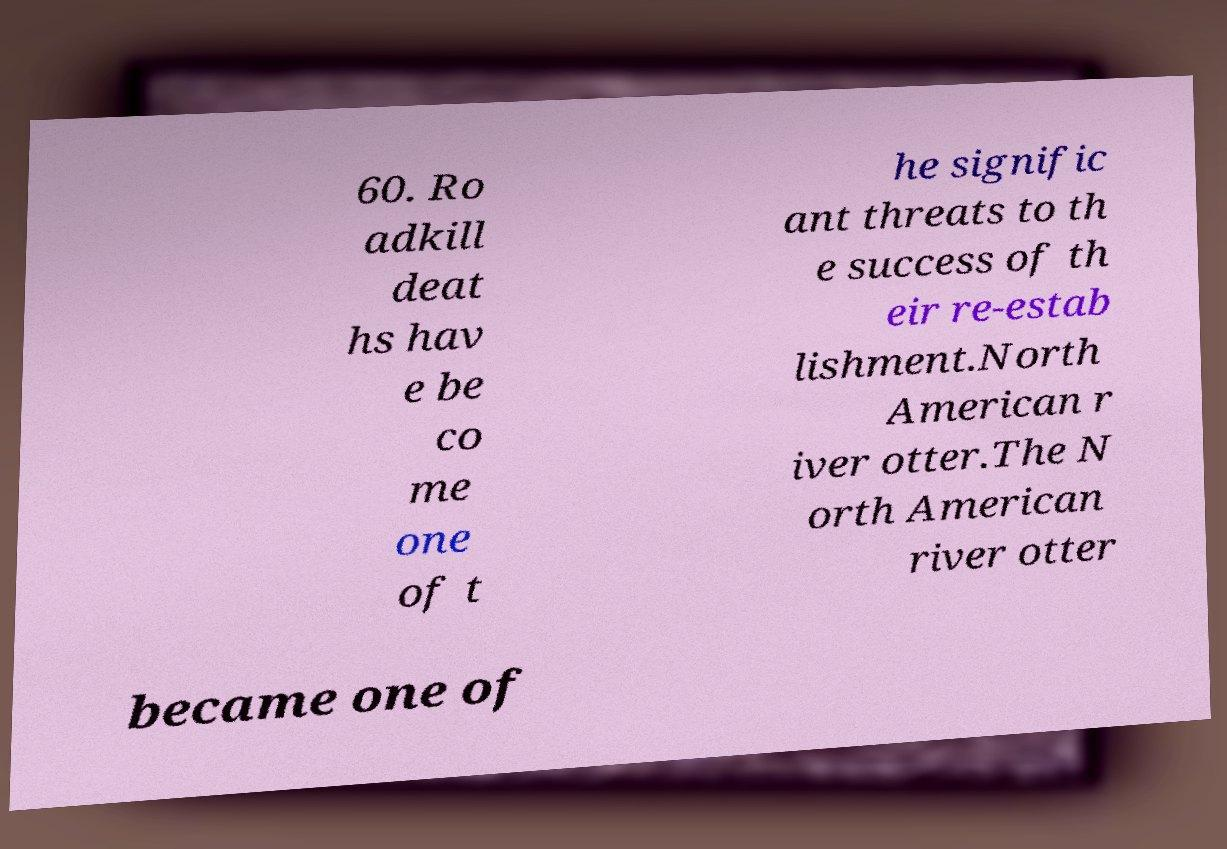Could you assist in decoding the text presented in this image and type it out clearly? 60. Ro adkill deat hs hav e be co me one of t he signific ant threats to th e success of th eir re-estab lishment.North American r iver otter.The N orth American river otter became one of 